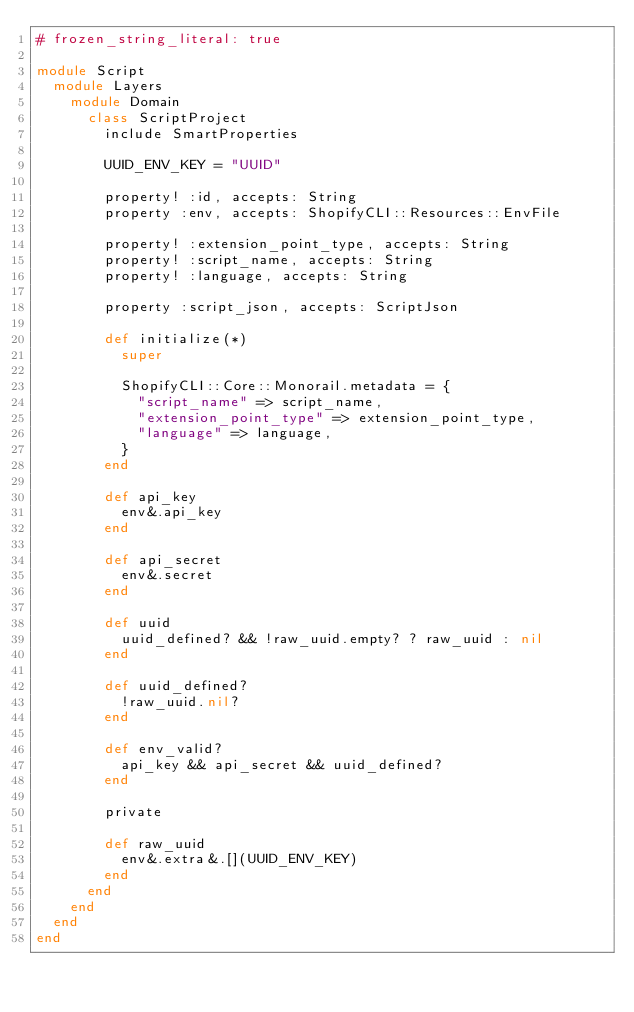Convert code to text. <code><loc_0><loc_0><loc_500><loc_500><_Ruby_># frozen_string_literal: true

module Script
  module Layers
    module Domain
      class ScriptProject
        include SmartProperties

        UUID_ENV_KEY = "UUID"

        property! :id, accepts: String
        property :env, accepts: ShopifyCLI::Resources::EnvFile

        property! :extension_point_type, accepts: String
        property! :script_name, accepts: String
        property! :language, accepts: String

        property :script_json, accepts: ScriptJson

        def initialize(*)
          super

          ShopifyCLI::Core::Monorail.metadata = {
            "script_name" => script_name,
            "extension_point_type" => extension_point_type,
            "language" => language,
          }
        end

        def api_key
          env&.api_key
        end

        def api_secret
          env&.secret
        end

        def uuid
          uuid_defined? && !raw_uuid.empty? ? raw_uuid : nil
        end

        def uuid_defined?
          !raw_uuid.nil?
        end

        def env_valid?
          api_key && api_secret && uuid_defined?
        end

        private

        def raw_uuid
          env&.extra&.[](UUID_ENV_KEY)
        end
      end
    end
  end
end
</code> 